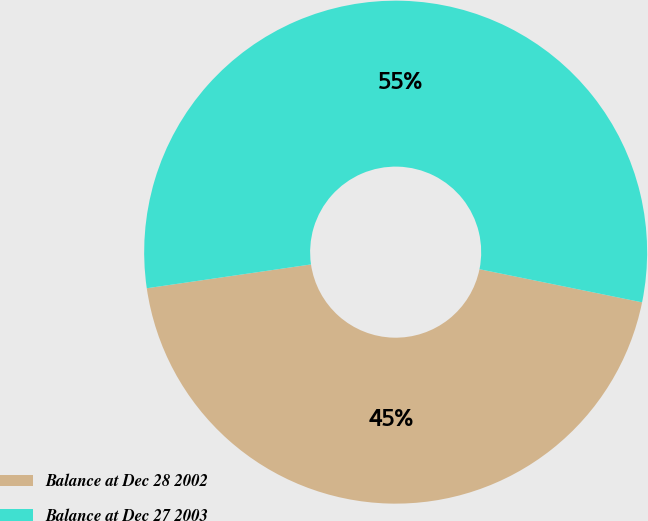Convert chart to OTSL. <chart><loc_0><loc_0><loc_500><loc_500><pie_chart><fcel>Balance at Dec 28 2002<fcel>Balance at Dec 27 2003<nl><fcel>44.51%<fcel>55.49%<nl></chart> 